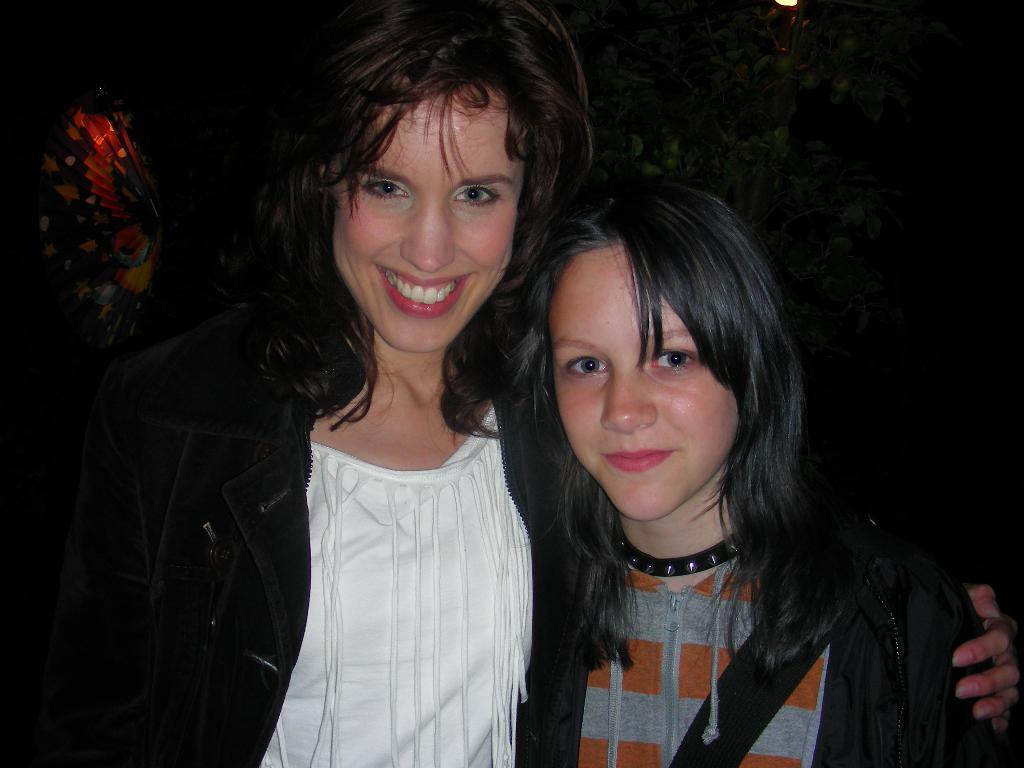How many women are in the image? There are two women in the image. What expressions do the women have? Both women are smiling. Can you describe the clothing of one of the women? One of the women is wearing a black and white dress. What can be seen in the background of the image? There are plants in the background of the image. What type of dime is visible on the table in the image? There is no dime present in the image. What scientific experiment is being conducted in the image? There is no scientific experiment being conducted in the image. 